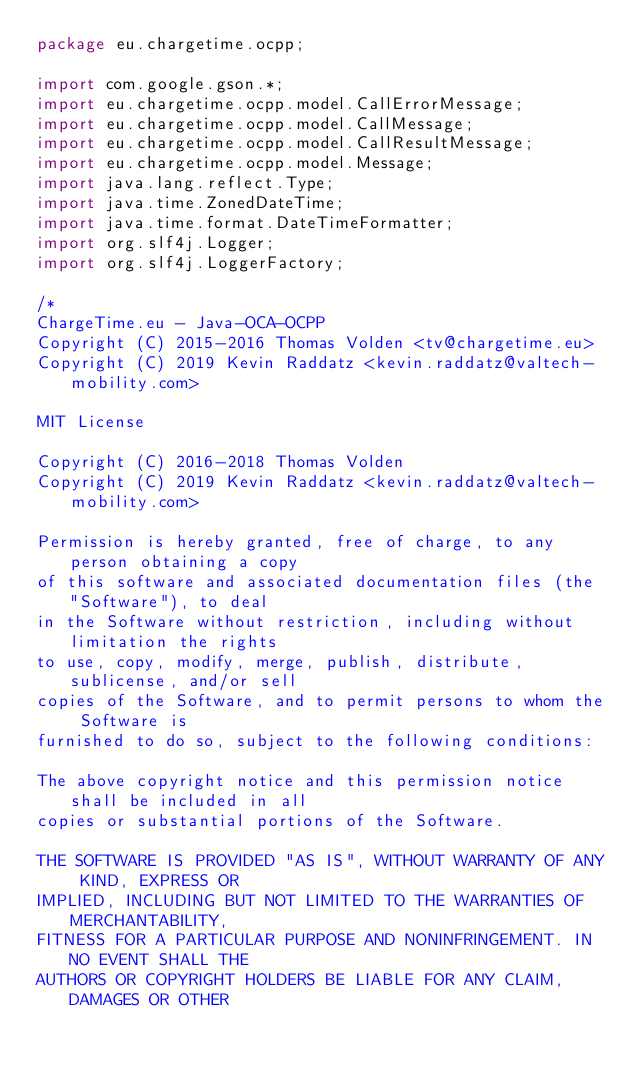<code> <loc_0><loc_0><loc_500><loc_500><_Java_>package eu.chargetime.ocpp;

import com.google.gson.*;
import eu.chargetime.ocpp.model.CallErrorMessage;
import eu.chargetime.ocpp.model.CallMessage;
import eu.chargetime.ocpp.model.CallResultMessage;
import eu.chargetime.ocpp.model.Message;
import java.lang.reflect.Type;
import java.time.ZonedDateTime;
import java.time.format.DateTimeFormatter;
import org.slf4j.Logger;
import org.slf4j.LoggerFactory;

/*
ChargeTime.eu - Java-OCA-OCPP
Copyright (C) 2015-2016 Thomas Volden <tv@chargetime.eu>
Copyright (C) 2019 Kevin Raddatz <kevin.raddatz@valtech-mobility.com>

MIT License

Copyright (C) 2016-2018 Thomas Volden
Copyright (C) 2019 Kevin Raddatz <kevin.raddatz@valtech-mobility.com>

Permission is hereby granted, free of charge, to any person obtaining a copy
of this software and associated documentation files (the "Software"), to deal
in the Software without restriction, including without limitation the rights
to use, copy, modify, merge, publish, distribute, sublicense, and/or sell
copies of the Software, and to permit persons to whom the Software is
furnished to do so, subject to the following conditions:

The above copyright notice and this permission notice shall be included in all
copies or substantial portions of the Software.

THE SOFTWARE IS PROVIDED "AS IS", WITHOUT WARRANTY OF ANY KIND, EXPRESS OR
IMPLIED, INCLUDING BUT NOT LIMITED TO THE WARRANTIES OF MERCHANTABILITY,
FITNESS FOR A PARTICULAR PURPOSE AND NONINFRINGEMENT. IN NO EVENT SHALL THE
AUTHORS OR COPYRIGHT HOLDERS BE LIABLE FOR ANY CLAIM, DAMAGES OR OTHER</code> 